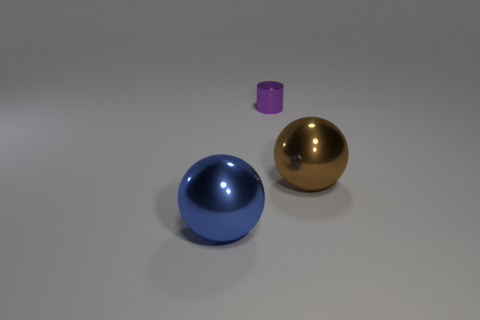What is the size of the thing that is on the right side of the blue metallic ball and to the left of the large brown object?
Make the answer very short. Small. What number of other objects are there of the same color as the metallic cylinder?
Your response must be concise. 0. What number of objects are big spheres left of the tiny metal thing or big objects?
Give a very brief answer. 2. What shape is the object that is both right of the large blue metallic object and in front of the tiny thing?
Make the answer very short. Sphere. Are there any other things that are the same size as the purple object?
Make the answer very short. No. The purple cylinder that is the same material as the large blue ball is what size?
Give a very brief answer. Small. How many things are big things to the left of the purple cylinder or large metallic objects on the left side of the purple object?
Provide a short and direct response. 1. Does the metal ball that is in front of the brown shiny thing have the same size as the brown shiny ball?
Offer a very short reply. Yes. There is a metallic ball that is on the right side of the blue metal object; what is its color?
Keep it short and to the point. Brown. The other big metallic object that is the same shape as the large blue shiny thing is what color?
Make the answer very short. Brown. 